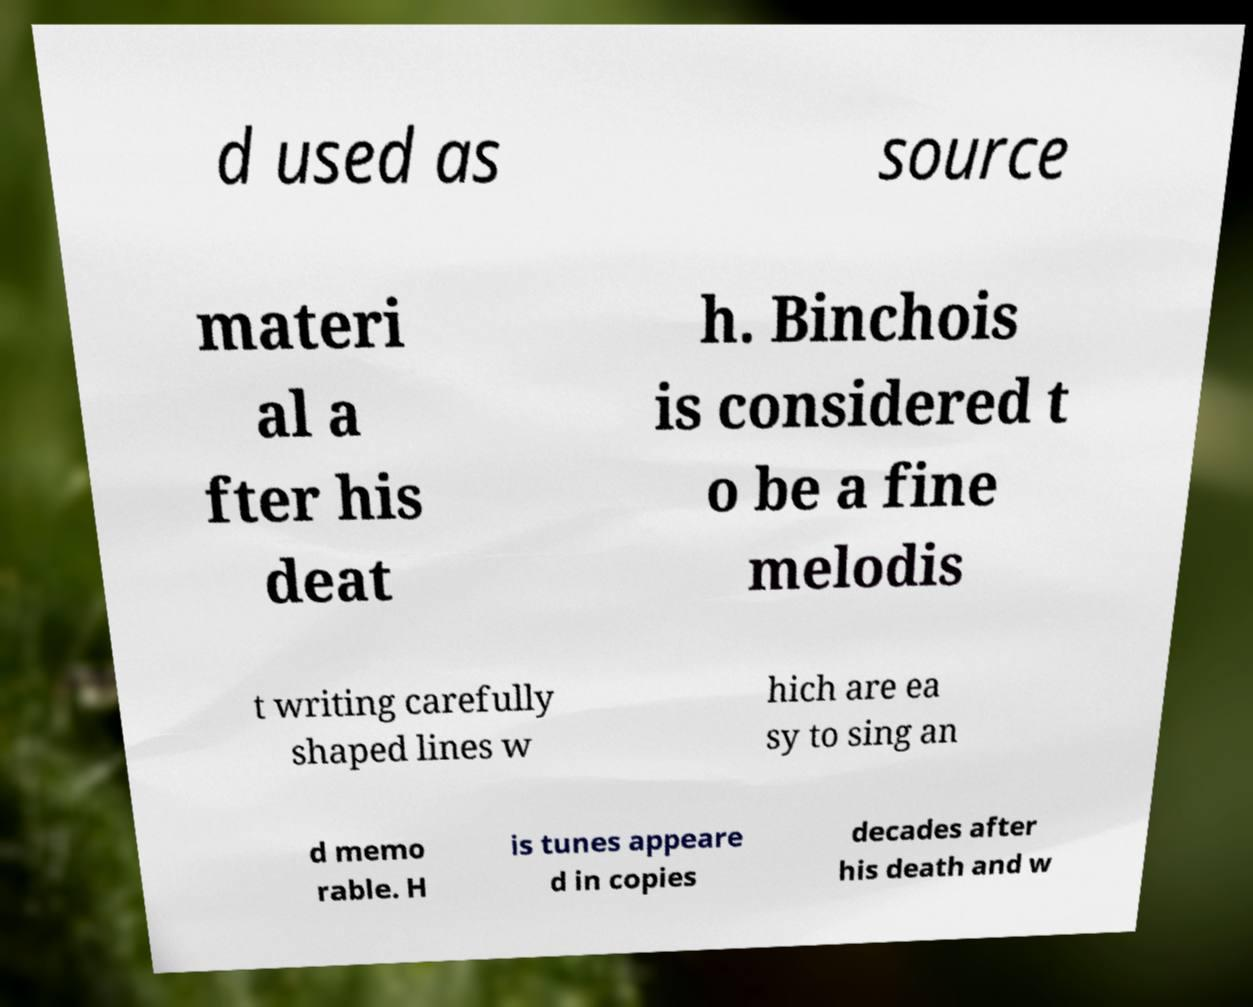What messages or text are displayed in this image? I need them in a readable, typed format. d used as source materi al a fter his deat h. Binchois is considered t o be a fine melodis t writing carefully shaped lines w hich are ea sy to sing an d memo rable. H is tunes appeare d in copies decades after his death and w 